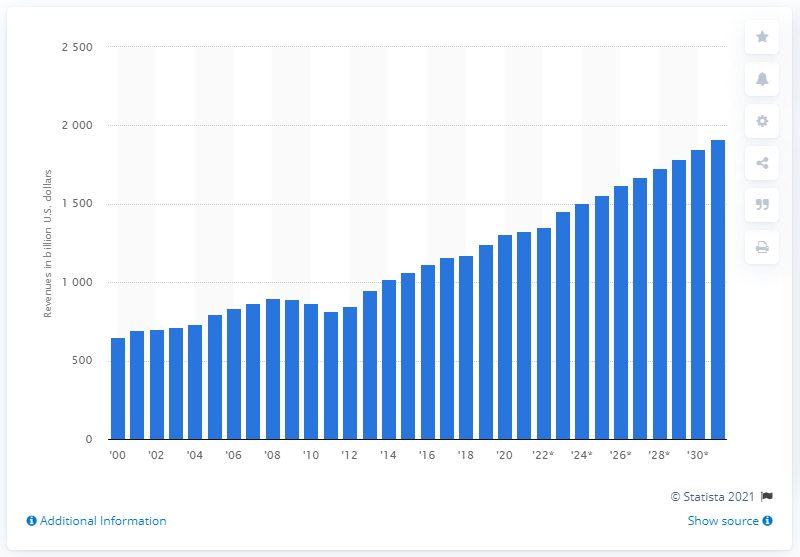Mention a couple of crucial points in this snapshot. The total revenue generated from payroll taxes in the United States in 2020 was approximately $1310 billion. The projected increase in payroll taxes revenue in 2031 is estimated to be 1914. 